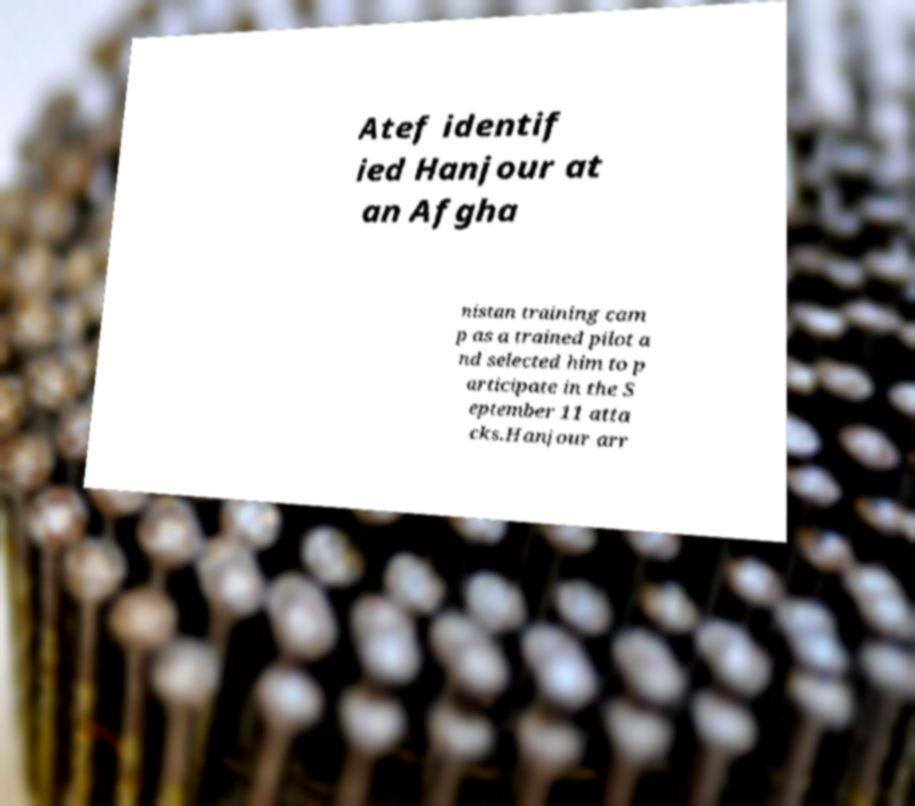What messages or text are displayed in this image? I need them in a readable, typed format. Atef identif ied Hanjour at an Afgha nistan training cam p as a trained pilot a nd selected him to p articipate in the S eptember 11 atta cks.Hanjour arr 